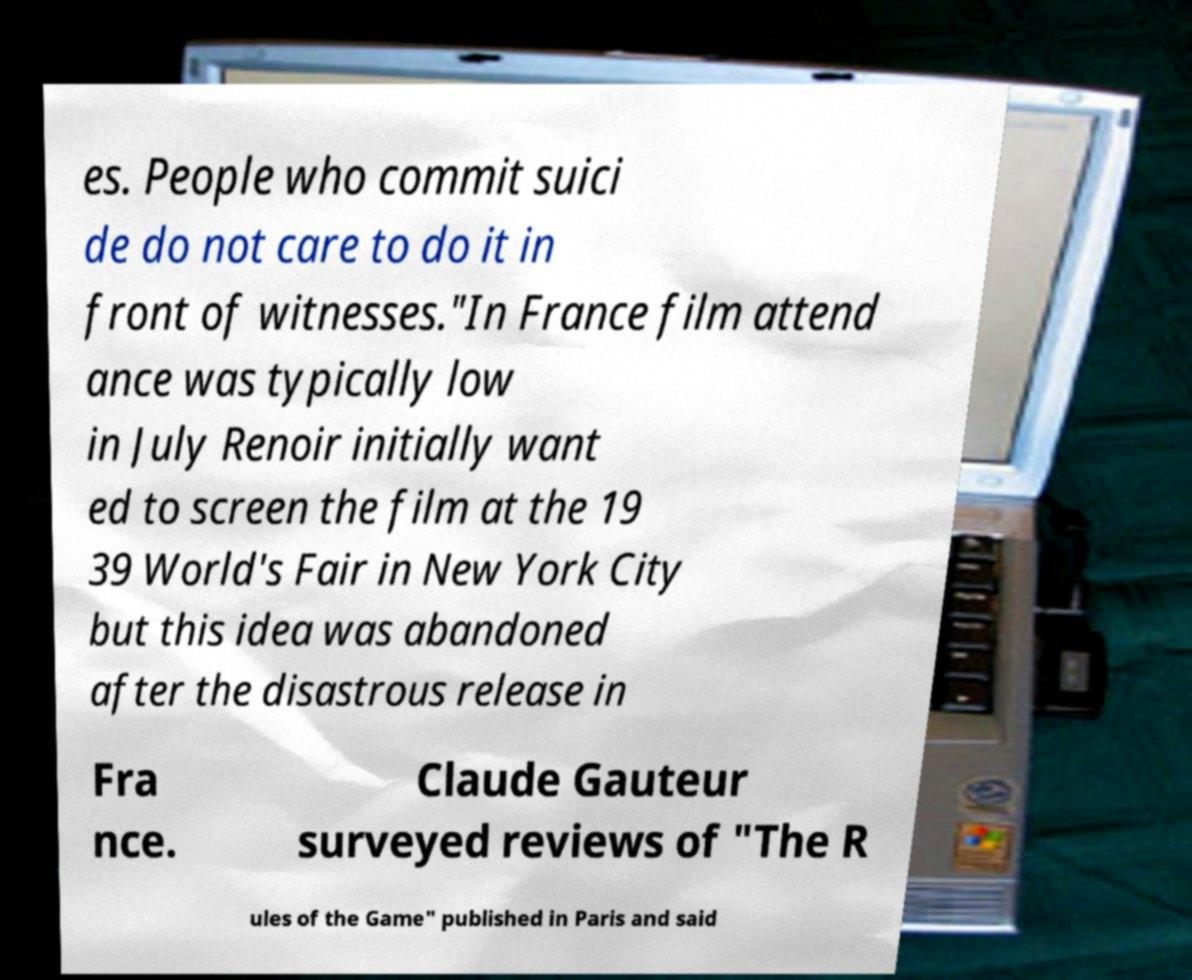Could you assist in decoding the text presented in this image and type it out clearly? es. People who commit suici de do not care to do it in front of witnesses."In France film attend ance was typically low in July Renoir initially want ed to screen the film at the 19 39 World's Fair in New York City but this idea was abandoned after the disastrous release in Fra nce. Claude Gauteur surveyed reviews of "The R ules of the Game" published in Paris and said 